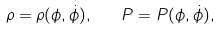<formula> <loc_0><loc_0><loc_500><loc_500>\rho = \rho ( \phi , \dot { \phi } ) , \quad P = P ( \phi , \dot { \phi } ) ,</formula> 